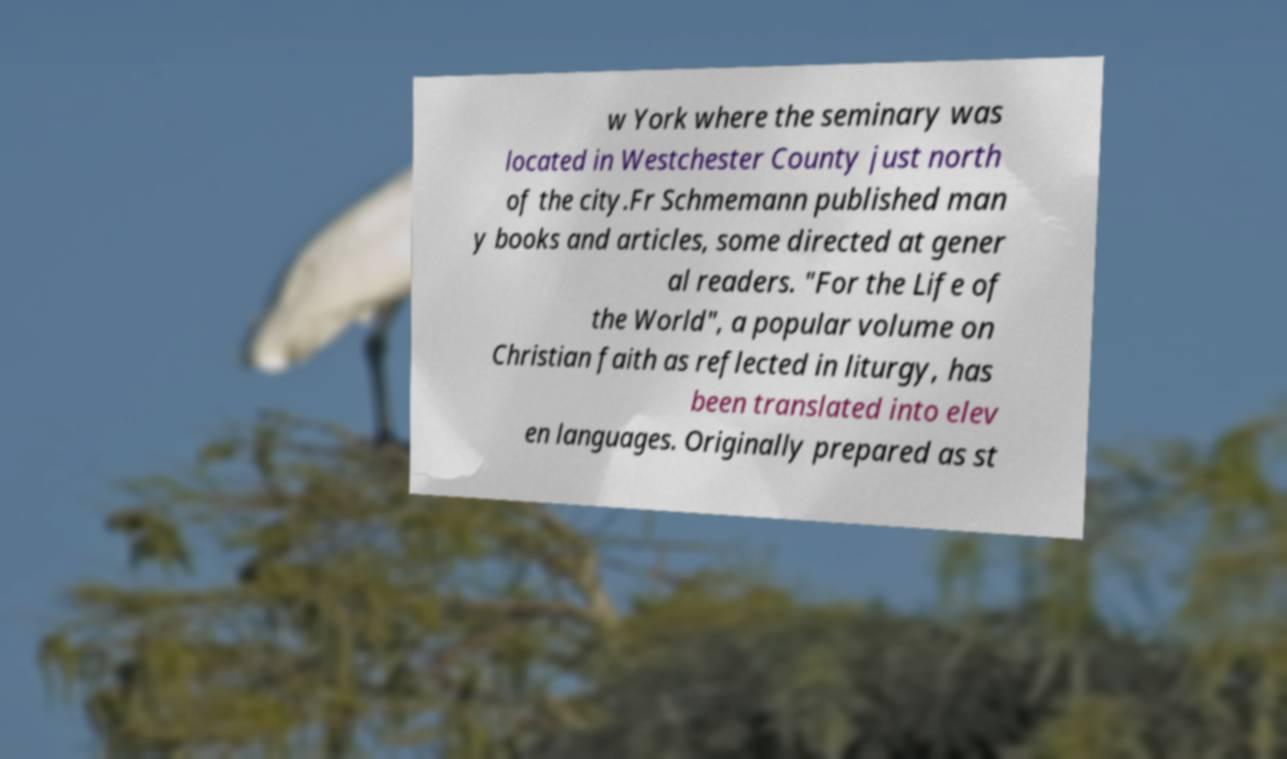Could you extract and type out the text from this image? w York where the seminary was located in Westchester County just north of the city.Fr Schmemann published man y books and articles, some directed at gener al readers. "For the Life of the World", a popular volume on Christian faith as reflected in liturgy, has been translated into elev en languages. Originally prepared as st 